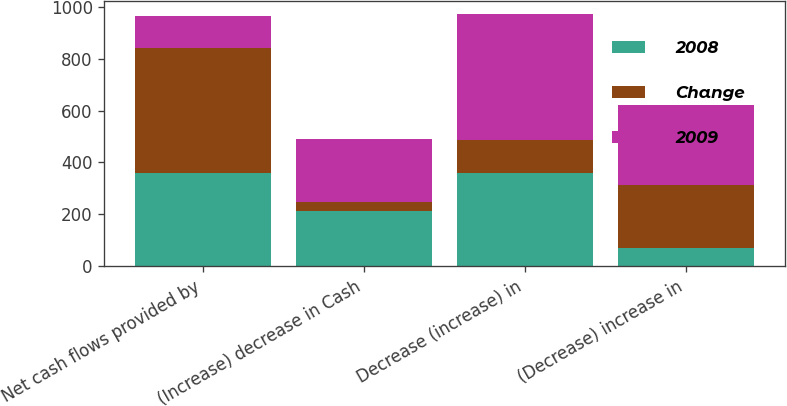<chart> <loc_0><loc_0><loc_500><loc_500><stacked_bar_chart><ecel><fcel>Net cash flows provided by<fcel>(Increase) decrease in Cash<fcel>Decrease (increase) in<fcel>(Decrease) increase in<nl><fcel>2008<fcel>358.8<fcel>212.8<fcel>358.6<fcel>69.3<nl><fcel>Change<fcel>482<fcel>32.7<fcel>128.7<fcel>242<nl><fcel>2009<fcel>123.2<fcel>245.5<fcel>487.3<fcel>311.3<nl></chart> 